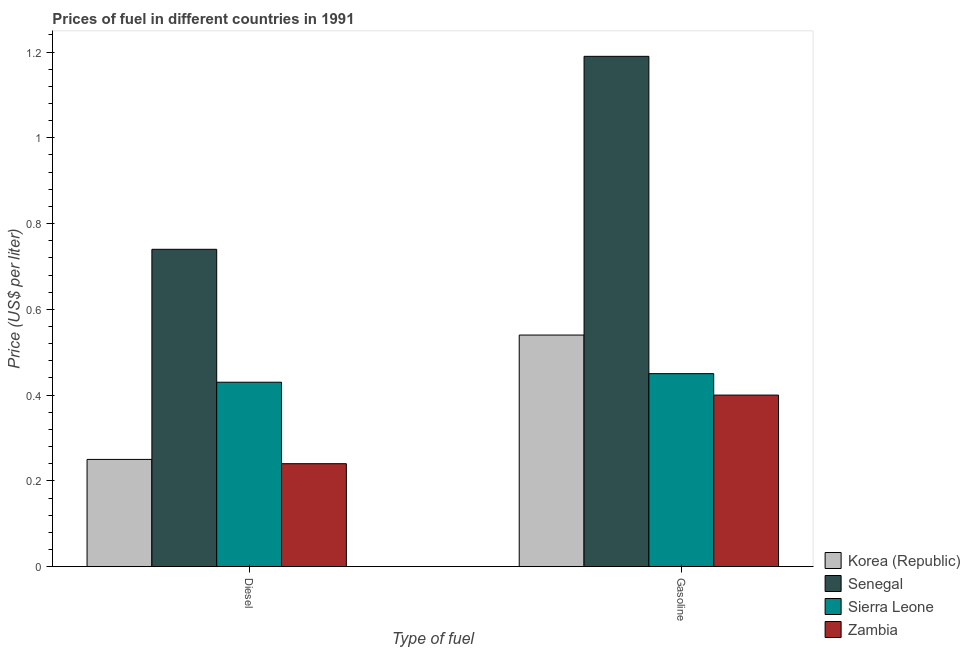How many different coloured bars are there?
Keep it short and to the point. 4. Are the number of bars per tick equal to the number of legend labels?
Keep it short and to the point. Yes. How many bars are there on the 2nd tick from the right?
Keep it short and to the point. 4. What is the label of the 1st group of bars from the left?
Provide a short and direct response. Diesel. Across all countries, what is the maximum diesel price?
Keep it short and to the point. 0.74. Across all countries, what is the minimum gasoline price?
Give a very brief answer. 0.4. In which country was the gasoline price maximum?
Keep it short and to the point. Senegal. In which country was the diesel price minimum?
Keep it short and to the point. Zambia. What is the total gasoline price in the graph?
Your answer should be compact. 2.58. What is the difference between the gasoline price in Zambia and that in Sierra Leone?
Provide a short and direct response. -0.05. What is the difference between the gasoline price in Sierra Leone and the diesel price in Korea (Republic)?
Offer a terse response. 0.2. What is the average gasoline price per country?
Give a very brief answer. 0.65. What is the difference between the diesel price and gasoline price in Senegal?
Your response must be concise. -0.45. What is the ratio of the diesel price in Senegal to that in Sierra Leone?
Ensure brevity in your answer.  1.72. In how many countries, is the gasoline price greater than the average gasoline price taken over all countries?
Offer a terse response. 1. What does the 3rd bar from the left in Diesel represents?
Keep it short and to the point. Sierra Leone. What does the 1st bar from the right in Diesel represents?
Keep it short and to the point. Zambia. How many countries are there in the graph?
Provide a succinct answer. 4. What is the difference between two consecutive major ticks on the Y-axis?
Provide a succinct answer. 0.2. Does the graph contain any zero values?
Your response must be concise. No. Where does the legend appear in the graph?
Offer a very short reply. Bottom right. How many legend labels are there?
Your answer should be compact. 4. What is the title of the graph?
Your answer should be compact. Prices of fuel in different countries in 1991. What is the label or title of the X-axis?
Your answer should be compact. Type of fuel. What is the label or title of the Y-axis?
Provide a short and direct response. Price (US$ per liter). What is the Price (US$ per liter) in Korea (Republic) in Diesel?
Offer a very short reply. 0.25. What is the Price (US$ per liter) in Senegal in Diesel?
Keep it short and to the point. 0.74. What is the Price (US$ per liter) of Sierra Leone in Diesel?
Offer a terse response. 0.43. What is the Price (US$ per liter) in Zambia in Diesel?
Make the answer very short. 0.24. What is the Price (US$ per liter) of Korea (Republic) in Gasoline?
Make the answer very short. 0.54. What is the Price (US$ per liter) in Senegal in Gasoline?
Provide a short and direct response. 1.19. What is the Price (US$ per liter) in Sierra Leone in Gasoline?
Provide a short and direct response. 0.45. What is the Price (US$ per liter) in Zambia in Gasoline?
Your response must be concise. 0.4. Across all Type of fuel, what is the maximum Price (US$ per liter) of Korea (Republic)?
Provide a succinct answer. 0.54. Across all Type of fuel, what is the maximum Price (US$ per liter) in Senegal?
Offer a very short reply. 1.19. Across all Type of fuel, what is the maximum Price (US$ per liter) in Sierra Leone?
Offer a terse response. 0.45. Across all Type of fuel, what is the minimum Price (US$ per liter) of Senegal?
Make the answer very short. 0.74. Across all Type of fuel, what is the minimum Price (US$ per liter) in Sierra Leone?
Provide a succinct answer. 0.43. Across all Type of fuel, what is the minimum Price (US$ per liter) of Zambia?
Provide a short and direct response. 0.24. What is the total Price (US$ per liter) of Korea (Republic) in the graph?
Provide a short and direct response. 0.79. What is the total Price (US$ per liter) of Senegal in the graph?
Keep it short and to the point. 1.93. What is the total Price (US$ per liter) of Sierra Leone in the graph?
Offer a very short reply. 0.88. What is the total Price (US$ per liter) in Zambia in the graph?
Offer a very short reply. 0.64. What is the difference between the Price (US$ per liter) of Korea (Republic) in Diesel and that in Gasoline?
Offer a very short reply. -0.29. What is the difference between the Price (US$ per liter) of Senegal in Diesel and that in Gasoline?
Ensure brevity in your answer.  -0.45. What is the difference between the Price (US$ per liter) of Sierra Leone in Diesel and that in Gasoline?
Offer a very short reply. -0.02. What is the difference between the Price (US$ per liter) in Zambia in Diesel and that in Gasoline?
Give a very brief answer. -0.16. What is the difference between the Price (US$ per liter) of Korea (Republic) in Diesel and the Price (US$ per liter) of Senegal in Gasoline?
Your answer should be compact. -0.94. What is the difference between the Price (US$ per liter) in Korea (Republic) in Diesel and the Price (US$ per liter) in Sierra Leone in Gasoline?
Ensure brevity in your answer.  -0.2. What is the difference between the Price (US$ per liter) of Korea (Republic) in Diesel and the Price (US$ per liter) of Zambia in Gasoline?
Your answer should be compact. -0.15. What is the difference between the Price (US$ per liter) in Senegal in Diesel and the Price (US$ per liter) in Sierra Leone in Gasoline?
Ensure brevity in your answer.  0.29. What is the difference between the Price (US$ per liter) of Senegal in Diesel and the Price (US$ per liter) of Zambia in Gasoline?
Make the answer very short. 0.34. What is the average Price (US$ per liter) of Korea (Republic) per Type of fuel?
Give a very brief answer. 0.4. What is the average Price (US$ per liter) of Sierra Leone per Type of fuel?
Keep it short and to the point. 0.44. What is the average Price (US$ per liter) in Zambia per Type of fuel?
Your answer should be very brief. 0.32. What is the difference between the Price (US$ per liter) in Korea (Republic) and Price (US$ per liter) in Senegal in Diesel?
Make the answer very short. -0.49. What is the difference between the Price (US$ per liter) in Korea (Republic) and Price (US$ per liter) in Sierra Leone in Diesel?
Provide a short and direct response. -0.18. What is the difference between the Price (US$ per liter) in Korea (Republic) and Price (US$ per liter) in Zambia in Diesel?
Give a very brief answer. 0.01. What is the difference between the Price (US$ per liter) in Senegal and Price (US$ per liter) in Sierra Leone in Diesel?
Give a very brief answer. 0.31. What is the difference between the Price (US$ per liter) of Sierra Leone and Price (US$ per liter) of Zambia in Diesel?
Provide a succinct answer. 0.19. What is the difference between the Price (US$ per liter) in Korea (Republic) and Price (US$ per liter) in Senegal in Gasoline?
Make the answer very short. -0.65. What is the difference between the Price (US$ per liter) in Korea (Republic) and Price (US$ per liter) in Sierra Leone in Gasoline?
Offer a terse response. 0.09. What is the difference between the Price (US$ per liter) in Korea (Republic) and Price (US$ per liter) in Zambia in Gasoline?
Your response must be concise. 0.14. What is the difference between the Price (US$ per liter) of Senegal and Price (US$ per liter) of Sierra Leone in Gasoline?
Provide a short and direct response. 0.74. What is the difference between the Price (US$ per liter) in Senegal and Price (US$ per liter) in Zambia in Gasoline?
Offer a terse response. 0.79. What is the difference between the Price (US$ per liter) in Sierra Leone and Price (US$ per liter) in Zambia in Gasoline?
Make the answer very short. 0.05. What is the ratio of the Price (US$ per liter) in Korea (Republic) in Diesel to that in Gasoline?
Offer a terse response. 0.46. What is the ratio of the Price (US$ per liter) of Senegal in Diesel to that in Gasoline?
Make the answer very short. 0.62. What is the ratio of the Price (US$ per liter) of Sierra Leone in Diesel to that in Gasoline?
Give a very brief answer. 0.96. What is the difference between the highest and the second highest Price (US$ per liter) in Korea (Republic)?
Keep it short and to the point. 0.29. What is the difference between the highest and the second highest Price (US$ per liter) of Senegal?
Provide a short and direct response. 0.45. What is the difference between the highest and the second highest Price (US$ per liter) in Sierra Leone?
Offer a very short reply. 0.02. What is the difference between the highest and the second highest Price (US$ per liter) of Zambia?
Ensure brevity in your answer.  0.16. What is the difference between the highest and the lowest Price (US$ per liter) of Korea (Republic)?
Provide a short and direct response. 0.29. What is the difference between the highest and the lowest Price (US$ per liter) of Senegal?
Provide a succinct answer. 0.45. What is the difference between the highest and the lowest Price (US$ per liter) of Sierra Leone?
Offer a very short reply. 0.02. What is the difference between the highest and the lowest Price (US$ per liter) in Zambia?
Provide a succinct answer. 0.16. 